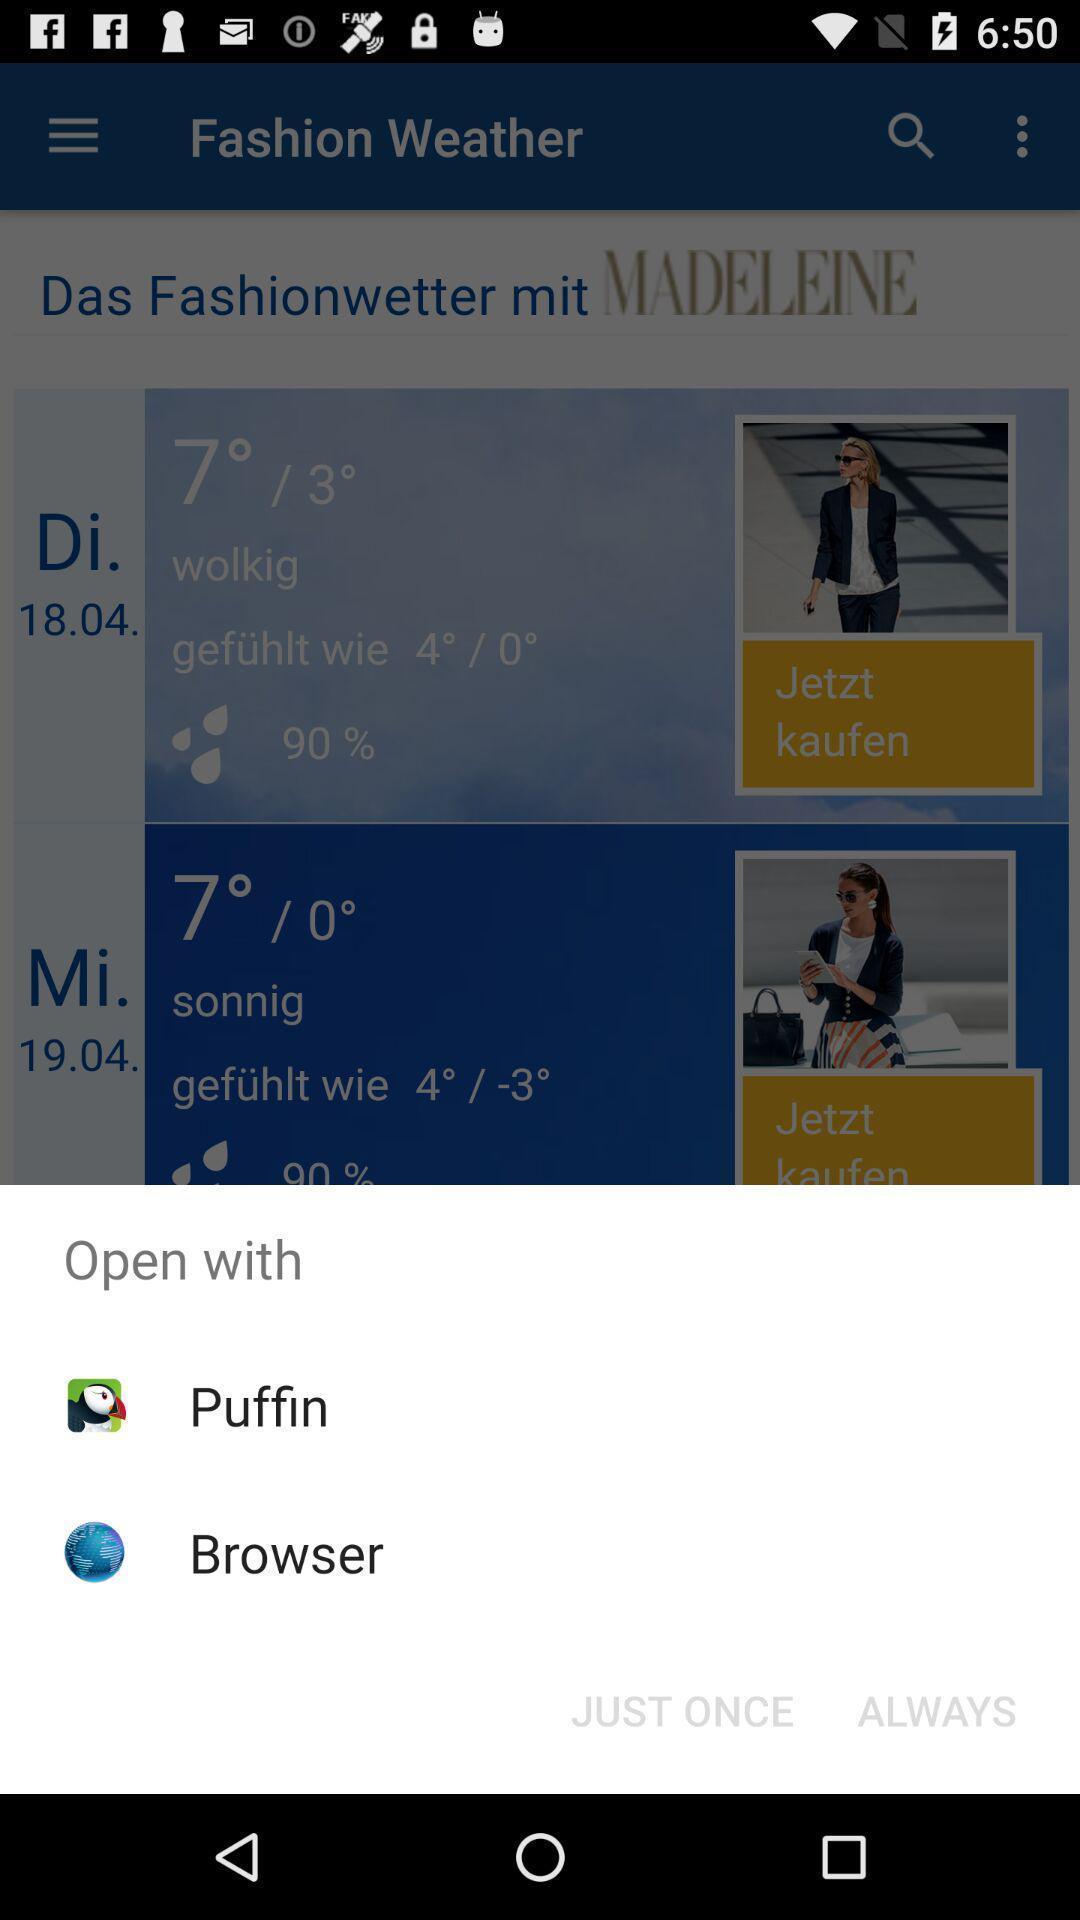Explain what's happening in this screen capture. Popup displaying apps to open a file in weather app. 